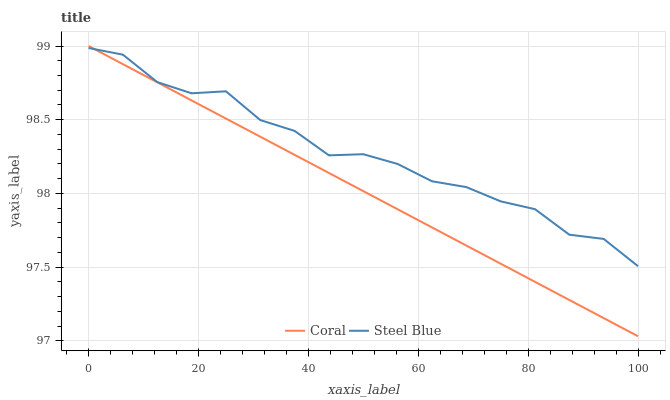Does Coral have the minimum area under the curve?
Answer yes or no. Yes. Does Steel Blue have the maximum area under the curve?
Answer yes or no. Yes. Does Steel Blue have the minimum area under the curve?
Answer yes or no. No. Is Coral the smoothest?
Answer yes or no. Yes. Is Steel Blue the roughest?
Answer yes or no. Yes. Is Steel Blue the smoothest?
Answer yes or no. No. Does Coral have the lowest value?
Answer yes or no. Yes. Does Steel Blue have the lowest value?
Answer yes or no. No. Does Coral have the highest value?
Answer yes or no. Yes. Does Steel Blue have the highest value?
Answer yes or no. No. Does Coral intersect Steel Blue?
Answer yes or no. Yes. Is Coral less than Steel Blue?
Answer yes or no. No. Is Coral greater than Steel Blue?
Answer yes or no. No. 